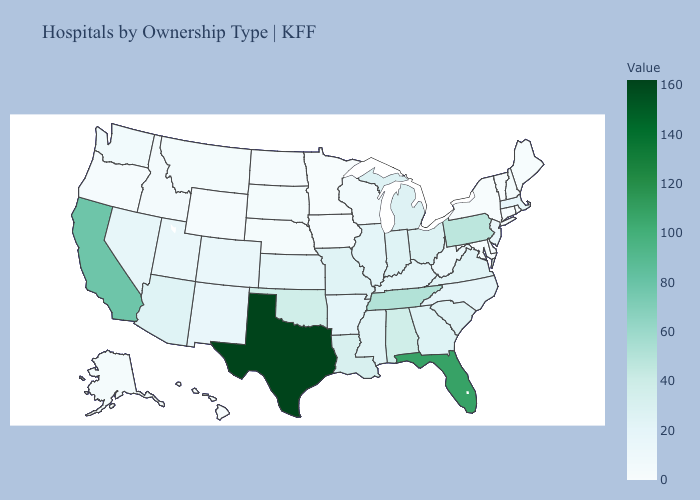Among the states that border Indiana , does Michigan have the lowest value?
Be succinct. No. Does Connecticut have a higher value than Tennessee?
Write a very short answer. No. Does Kansas have a lower value than Florida?
Keep it brief. Yes. Among the states that border Kansas , which have the highest value?
Keep it brief. Oklahoma. 